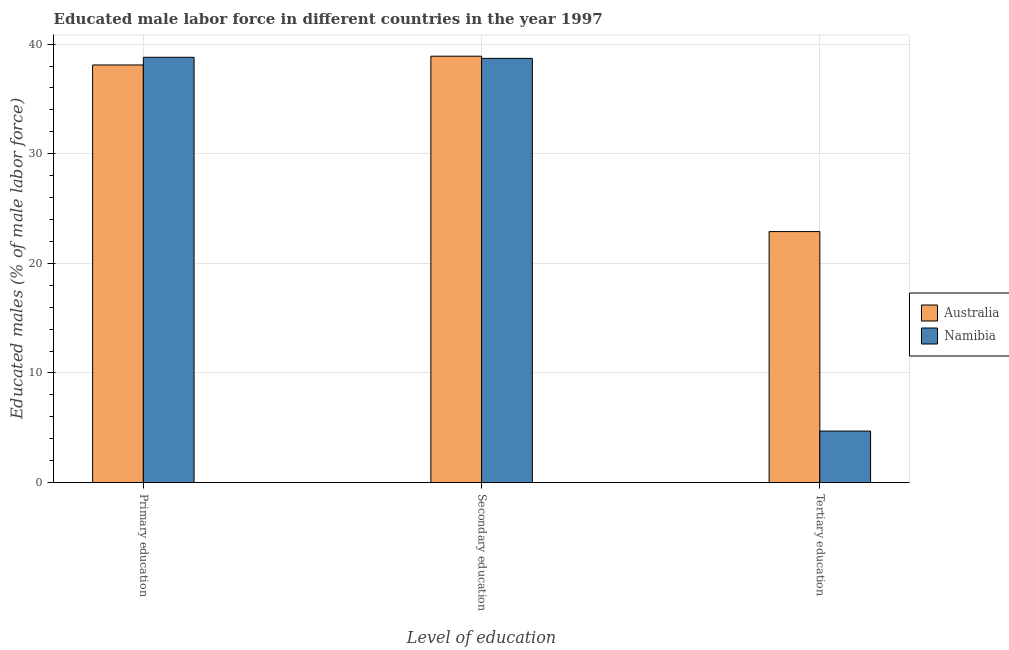How many bars are there on the 2nd tick from the left?
Your answer should be compact. 2. What is the label of the 3rd group of bars from the left?
Ensure brevity in your answer.  Tertiary education. What is the percentage of male labor force who received tertiary education in Australia?
Provide a succinct answer. 22.9. Across all countries, what is the maximum percentage of male labor force who received primary education?
Your answer should be very brief. 38.8. Across all countries, what is the minimum percentage of male labor force who received secondary education?
Give a very brief answer. 38.7. In which country was the percentage of male labor force who received secondary education maximum?
Ensure brevity in your answer.  Australia. In which country was the percentage of male labor force who received tertiary education minimum?
Your response must be concise. Namibia. What is the total percentage of male labor force who received primary education in the graph?
Your answer should be very brief. 76.9. What is the difference between the percentage of male labor force who received tertiary education in Australia and that in Namibia?
Keep it short and to the point. 18.2. What is the difference between the percentage of male labor force who received secondary education in Australia and the percentage of male labor force who received primary education in Namibia?
Your answer should be compact. 0.1. What is the average percentage of male labor force who received tertiary education per country?
Provide a succinct answer. 13.8. What is the difference between the percentage of male labor force who received secondary education and percentage of male labor force who received primary education in Australia?
Give a very brief answer. 0.8. What is the ratio of the percentage of male labor force who received primary education in Namibia to that in Australia?
Make the answer very short. 1.02. What is the difference between the highest and the second highest percentage of male labor force who received secondary education?
Make the answer very short. 0.2. What is the difference between the highest and the lowest percentage of male labor force who received tertiary education?
Offer a terse response. 18.2. What does the 2nd bar from the left in Primary education represents?
Ensure brevity in your answer.  Namibia. Is it the case that in every country, the sum of the percentage of male labor force who received primary education and percentage of male labor force who received secondary education is greater than the percentage of male labor force who received tertiary education?
Offer a very short reply. Yes. How many bars are there?
Your response must be concise. 6. Are the values on the major ticks of Y-axis written in scientific E-notation?
Provide a succinct answer. No. Where does the legend appear in the graph?
Provide a succinct answer. Center right. How are the legend labels stacked?
Your answer should be very brief. Vertical. What is the title of the graph?
Your answer should be compact. Educated male labor force in different countries in the year 1997. Does "Paraguay" appear as one of the legend labels in the graph?
Provide a short and direct response. No. What is the label or title of the X-axis?
Offer a terse response. Level of education. What is the label or title of the Y-axis?
Make the answer very short. Educated males (% of male labor force). What is the Educated males (% of male labor force) in Australia in Primary education?
Offer a terse response. 38.1. What is the Educated males (% of male labor force) in Namibia in Primary education?
Ensure brevity in your answer.  38.8. What is the Educated males (% of male labor force) in Australia in Secondary education?
Offer a very short reply. 38.9. What is the Educated males (% of male labor force) of Namibia in Secondary education?
Offer a very short reply. 38.7. What is the Educated males (% of male labor force) of Australia in Tertiary education?
Your response must be concise. 22.9. What is the Educated males (% of male labor force) of Namibia in Tertiary education?
Offer a very short reply. 4.7. Across all Level of education, what is the maximum Educated males (% of male labor force) of Australia?
Keep it short and to the point. 38.9. Across all Level of education, what is the maximum Educated males (% of male labor force) of Namibia?
Ensure brevity in your answer.  38.8. Across all Level of education, what is the minimum Educated males (% of male labor force) of Australia?
Offer a terse response. 22.9. Across all Level of education, what is the minimum Educated males (% of male labor force) of Namibia?
Your answer should be compact. 4.7. What is the total Educated males (% of male labor force) of Australia in the graph?
Offer a terse response. 99.9. What is the total Educated males (% of male labor force) in Namibia in the graph?
Make the answer very short. 82.2. What is the difference between the Educated males (% of male labor force) in Australia in Primary education and that in Secondary education?
Provide a succinct answer. -0.8. What is the difference between the Educated males (% of male labor force) in Namibia in Primary education and that in Secondary education?
Offer a terse response. 0.1. What is the difference between the Educated males (% of male labor force) in Australia in Primary education and that in Tertiary education?
Your answer should be compact. 15.2. What is the difference between the Educated males (% of male labor force) of Namibia in Primary education and that in Tertiary education?
Give a very brief answer. 34.1. What is the difference between the Educated males (% of male labor force) of Australia in Secondary education and that in Tertiary education?
Your answer should be very brief. 16. What is the difference between the Educated males (% of male labor force) of Australia in Primary education and the Educated males (% of male labor force) of Namibia in Tertiary education?
Ensure brevity in your answer.  33.4. What is the difference between the Educated males (% of male labor force) of Australia in Secondary education and the Educated males (% of male labor force) of Namibia in Tertiary education?
Give a very brief answer. 34.2. What is the average Educated males (% of male labor force) of Australia per Level of education?
Provide a succinct answer. 33.3. What is the average Educated males (% of male labor force) in Namibia per Level of education?
Provide a short and direct response. 27.4. What is the difference between the Educated males (% of male labor force) in Australia and Educated males (% of male labor force) in Namibia in Secondary education?
Your response must be concise. 0.2. What is the difference between the Educated males (% of male labor force) in Australia and Educated males (% of male labor force) in Namibia in Tertiary education?
Give a very brief answer. 18.2. What is the ratio of the Educated males (% of male labor force) of Australia in Primary education to that in Secondary education?
Your answer should be compact. 0.98. What is the ratio of the Educated males (% of male labor force) of Australia in Primary education to that in Tertiary education?
Keep it short and to the point. 1.66. What is the ratio of the Educated males (% of male labor force) in Namibia in Primary education to that in Tertiary education?
Make the answer very short. 8.26. What is the ratio of the Educated males (% of male labor force) of Australia in Secondary education to that in Tertiary education?
Ensure brevity in your answer.  1.7. What is the ratio of the Educated males (% of male labor force) in Namibia in Secondary education to that in Tertiary education?
Offer a very short reply. 8.23. What is the difference between the highest and the second highest Educated males (% of male labor force) in Namibia?
Make the answer very short. 0.1. What is the difference between the highest and the lowest Educated males (% of male labor force) of Australia?
Offer a terse response. 16. What is the difference between the highest and the lowest Educated males (% of male labor force) of Namibia?
Keep it short and to the point. 34.1. 